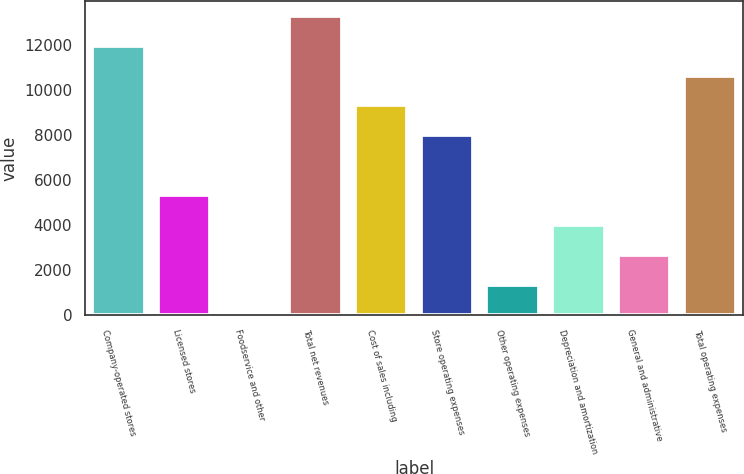Convert chart. <chart><loc_0><loc_0><loc_500><loc_500><bar_chart><fcel>Company-operated stores<fcel>Licensed stores<fcel>Foodservice and other<fcel>Total net revenues<fcel>Cost of sales including<fcel>Store operating expenses<fcel>Other operating expenses<fcel>Depreciation and amortization<fcel>General and administrative<fcel>Total operating expenses<nl><fcel>11967.4<fcel>5337.4<fcel>33.4<fcel>13293.4<fcel>9315.4<fcel>7989.4<fcel>1359.4<fcel>4011.4<fcel>2685.4<fcel>10641.4<nl></chart> 